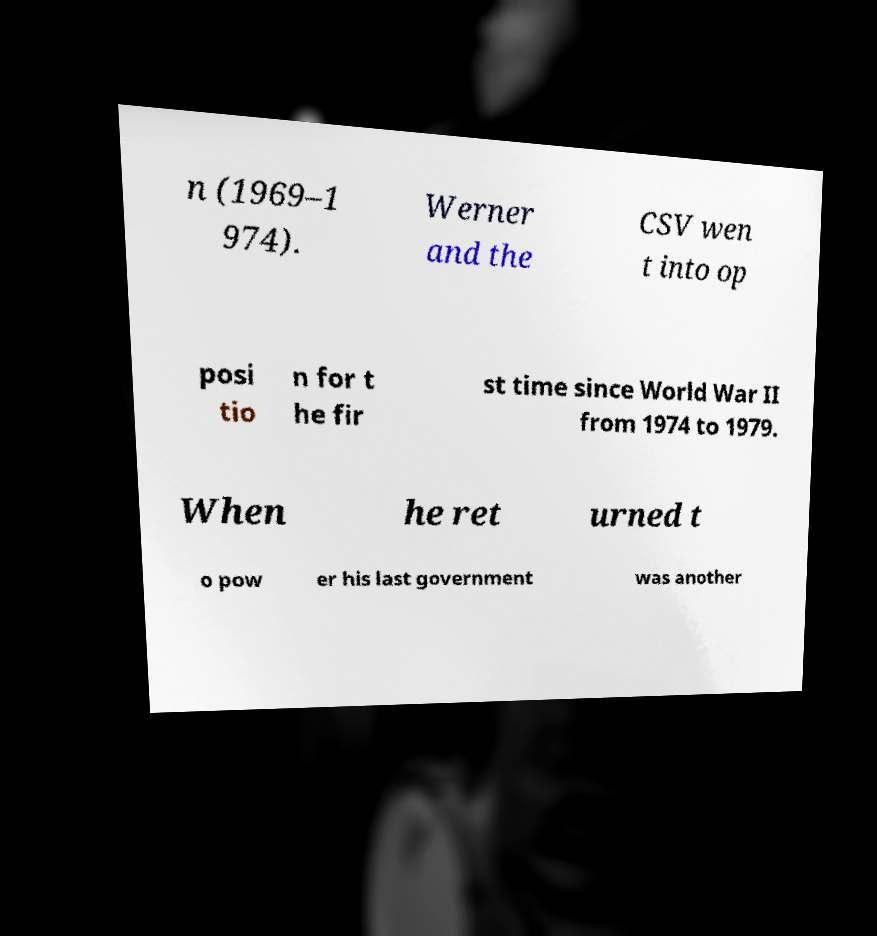What messages or text are displayed in this image? I need them in a readable, typed format. n (1969–1 974). Werner and the CSV wen t into op posi tio n for t he fir st time since World War II from 1974 to 1979. When he ret urned t o pow er his last government was another 